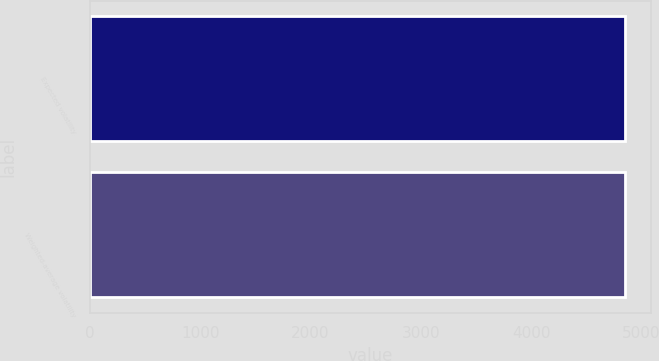Convert chart. <chart><loc_0><loc_0><loc_500><loc_500><bar_chart><fcel>Expected volatility<fcel>Weighted-average volatility<nl><fcel>4849<fcel>4849.1<nl></chart> 